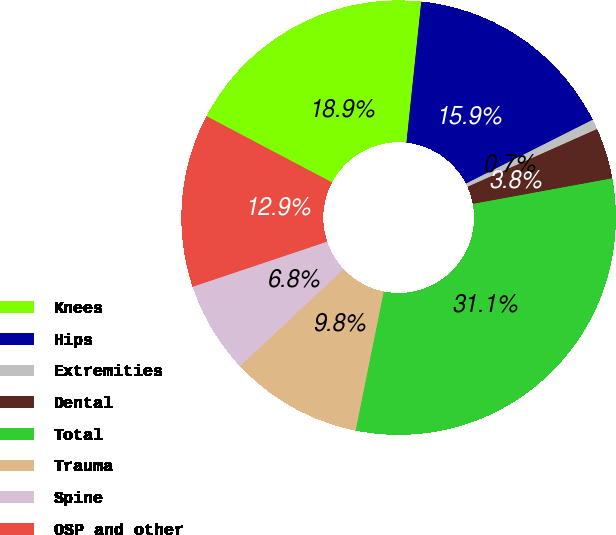Convert chart to OTSL. <chart><loc_0><loc_0><loc_500><loc_500><pie_chart><fcel>Knees<fcel>Hips<fcel>Extremities<fcel>Dental<fcel>Total<fcel>Trauma<fcel>Spine<fcel>OSP and other<nl><fcel>18.94%<fcel>15.91%<fcel>0.75%<fcel>3.79%<fcel>31.07%<fcel>9.85%<fcel>6.82%<fcel>12.88%<nl></chart> 